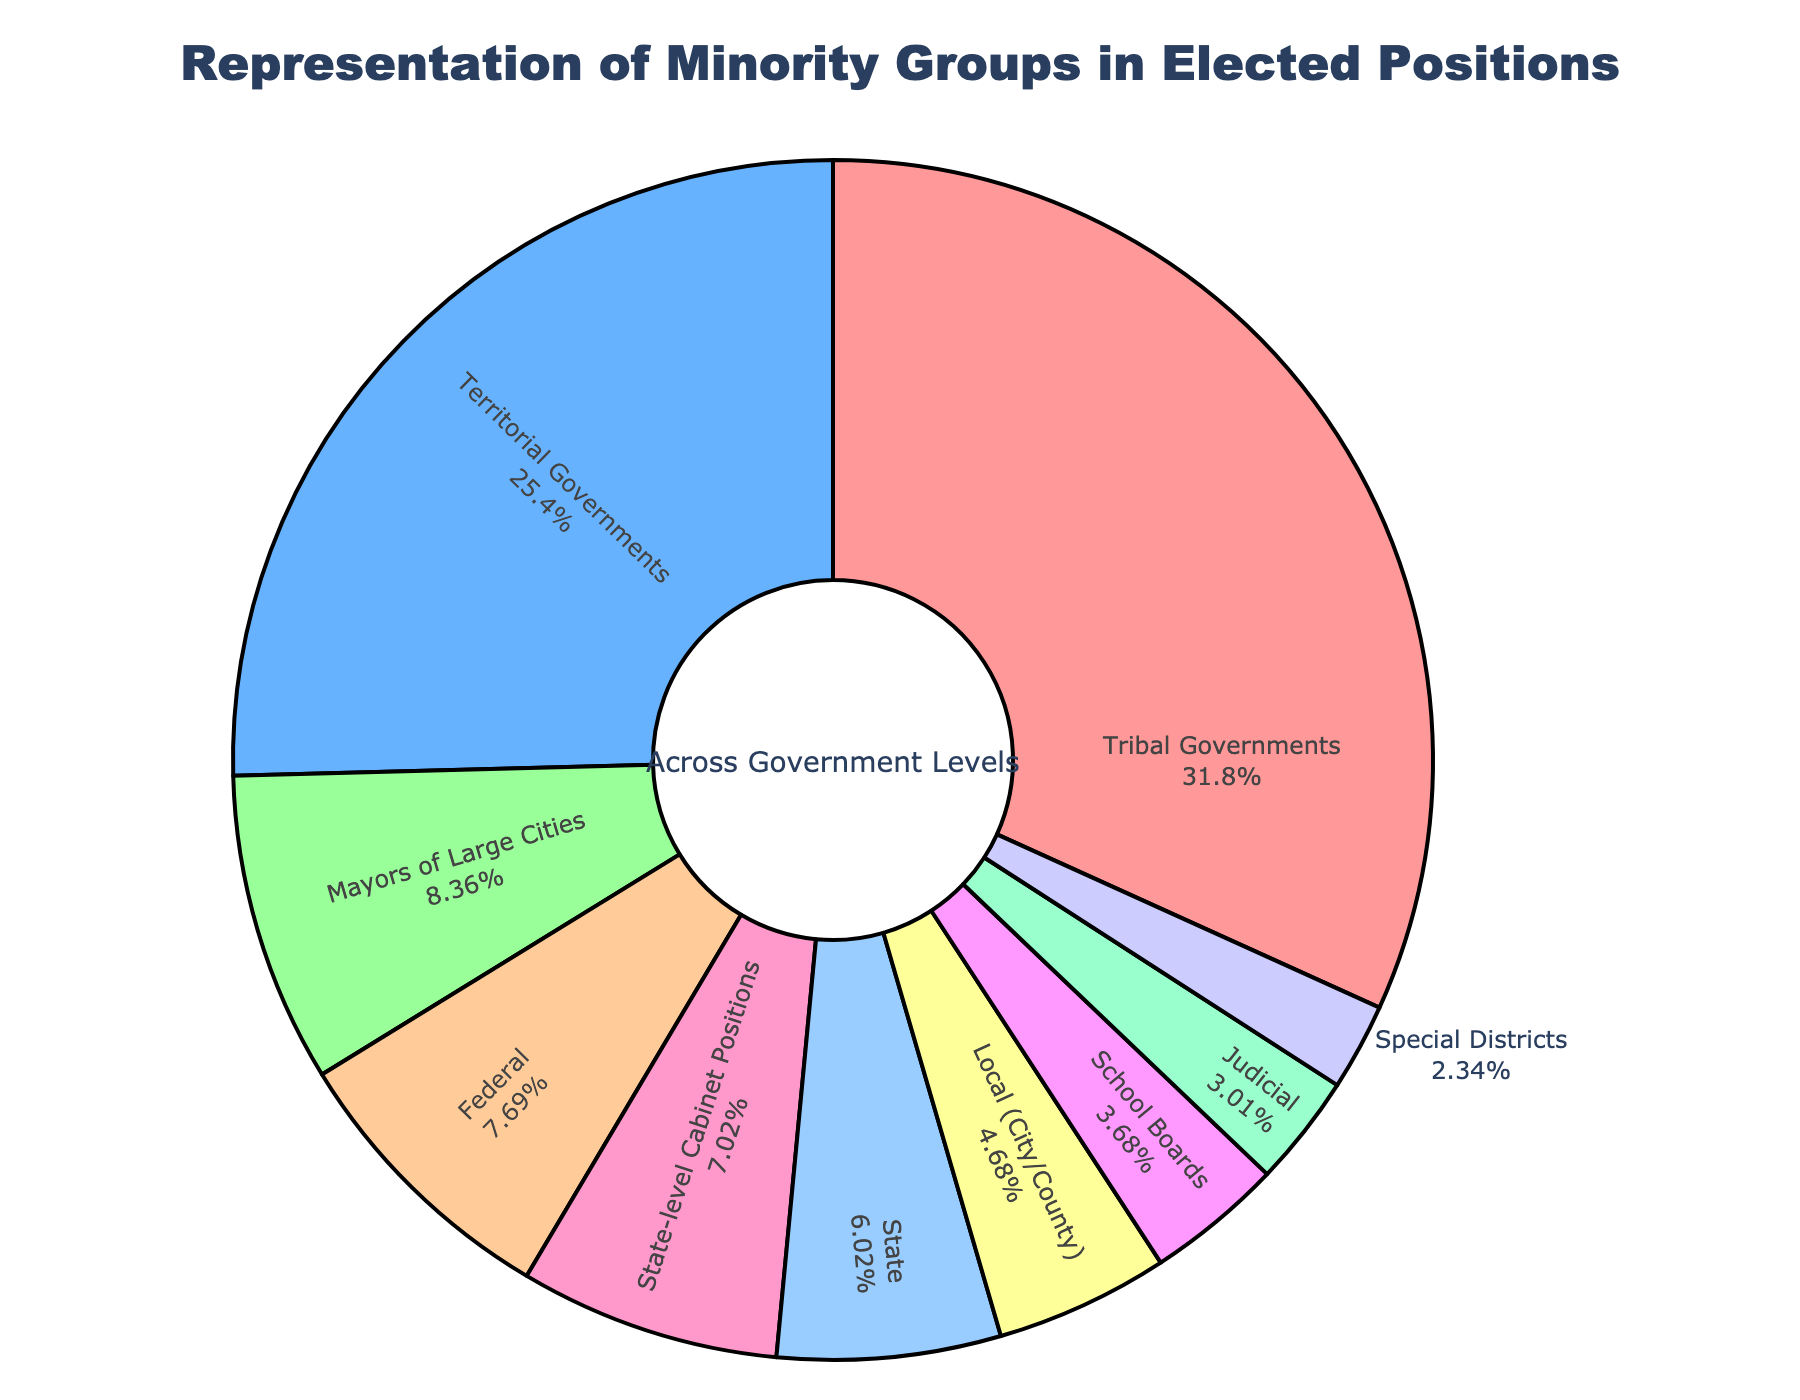Which level of government has the highest percentage of minority representatives? The pie chart shows that Tribal Governments have the highest percentage of minority representatives.
Answer: Tribal Governments Which level of government has the lowest representation of minority groups? By looking at the pie chart, we can see that Special Districts have the smallest slice, indicating they have the lowest percentage.
Answer: Special Districts How much higher is the percentage of minority representatives in Tribal Governments compared to State? Tribal Governments have 95% and State has 18%. Subtracting these gives 95 - 18 = 77.
Answer: 77% What is the combined percentage of minority representatives in Federal, State, and Local levels of government? Federal has 23%, State has 18%, and Local has 14%. Adding them together yields 23 + 18 + 14 = 55.
Answer: 55% Which two levels of government have percentages closest to each other? State-level Cabinet Positions and Federal governments have percentages of 21% and 23%, which are the closest.
Answer: State-level Cabinet Positions and Federal governments What percentage of total minority representatives falls within Territorial Governments and Mayors of Large Cities combined? Territorial Governments have 76% and Mayors of Large Cities have 25%. Adding them together gives 76 + 25 = 101, but visually you can see one slice includes another, indicating an overlap which is visually accurate to account as a sum percentage lower than 100%.
Answer: 101% Between which levels of government is there a 4% difference in minority representation? Local (City/County) and School Boards are 14% and 11% respectively. The difference is 14 - 11 = 3%. Among others, Federal and Mayors of Large Cities are 2% apart (25-23).
Answer: Local (City/County) and School Boards Is the representation of minority groups greater at the Federal or State-level Cabinet positions? The pie chart shows the Federal has 23% and State-level Cabinet Positions have 21%, so Federal is greater.
Answer: Federal Which category has almost three times the representation of minority groups compared to the Judicial level? The Federal category with 23% is almost three times more than the Judicial level which is 9%.
Answer: Federal 